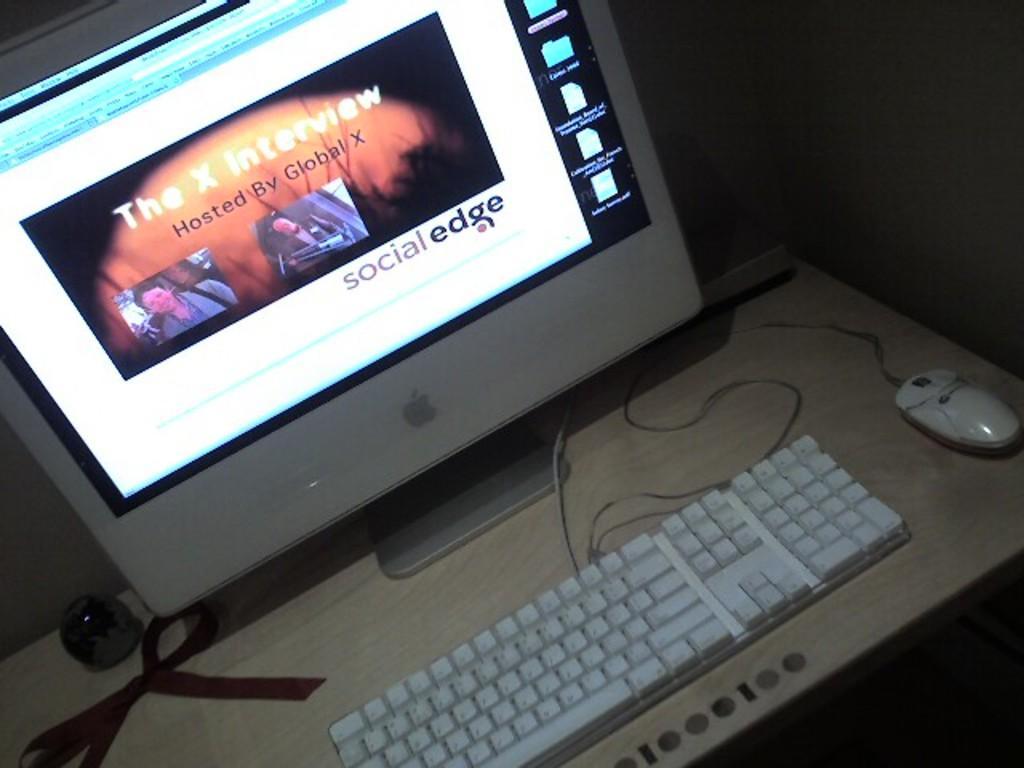Could you give a brief overview of what you see in this image? There is one desktop, keyboard and a mouse are present on a table as we can see in the middle of this image. 